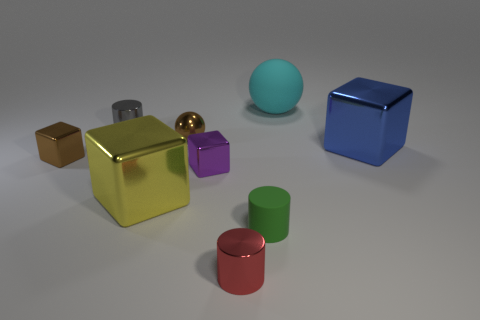Add 1 purple cubes. How many objects exist? 10 Subtract all cylinders. How many objects are left? 6 Add 8 blue metal objects. How many blue metal objects are left? 9 Add 8 large cyan spheres. How many large cyan spheres exist? 9 Subtract 1 cyan spheres. How many objects are left? 8 Subtract all large red metallic objects. Subtract all tiny red metallic things. How many objects are left? 8 